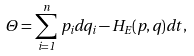Convert formula to latex. <formula><loc_0><loc_0><loc_500><loc_500>\Theta = \sum _ { i = 1 } ^ { n } \, p _ { i } d q _ { i } - H _ { E } ( p , q ) d t \, ,</formula> 